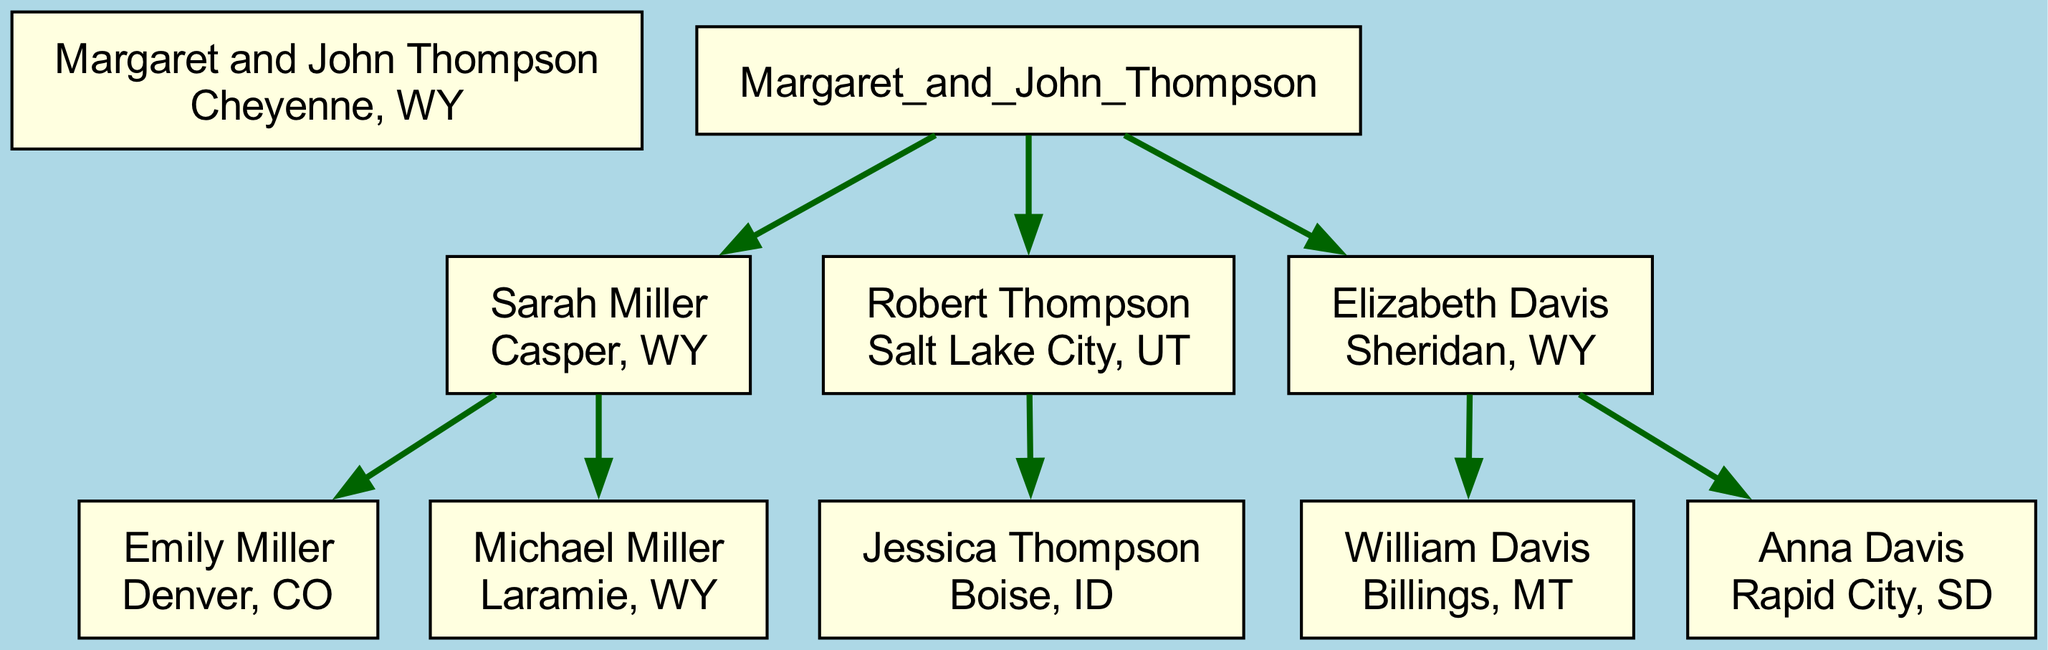What is the location of Margaret and John Thompson? In the diagram, the root node representing Margaret and John Thompson lists their location as Cheyenne, WY. This is directly shown under their names.
Answer: Cheyenne, WY How many children do Margaret and John Thompson have? The diagram displays three nodes branching from the root node, each representing one of their children: Sarah Miller, Robert Thompson, and Elizabeth Davis. Therefore, the count of children is three.
Answer: 3 Where does Emily Miller live? Looking at the children of Sarah Miller, the node for Emily Miller indicates her location as Denver, CO. This is shown beneath her name in the diagram.
Answer: Denver, CO Which child of Elizabeth Davis lives in Billings, MT? Reviewing the children of Elizabeth Davis, the node for William Davis specifies that he lives in Billings, MT. This can be found directly beneath his name in the diagram.
Answer: William Davis Which state has the most family members represented in the diagram? By examining the locations of all listed family members, Wyoming has the most representatives: Margaret and John Thompson, Sarah Miller, Michael Miller, and Elizabeth Davis, which totals four individuals from that state.
Answer: Wyoming How many states are represented by the descendants of Margaret and John Thompson? Analyzing the location of each family member shows that they are spread across six states: Wyoming, Utah, Colorado, Idaho, Montana, and South Dakota. Each person’s location needs to be counted for this total.
Answer: 6 Who is the only grandchild of Margaret and John Thompson living in Boise, ID? In the diagram, the child of Robert Thompson listed as living in Boise, ID is Jessica Thompson. This can be identified under Robert's node.
Answer: Jessica Thompson Which two locations are associated with Elizabeth Davis's children? The two children of Elizabeth Davis are William Davis, who lives in Billings, MT, and Anna Davis, who resides in Rapid City, SD. Both locations are shown beneath their names in the diagram.
Answer: Billings, MT and Rapid City, SD How many grandchildren does Sarah Miller have? Upon reviewing Sarah Miller's children, the diagram indicates that she has two grandchildren: Emily Miller and Michael Miller, who have been marked under her name as her children.
Answer: 2 